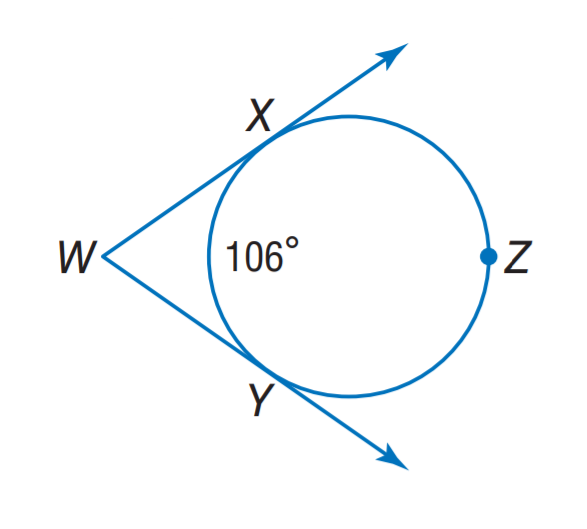Answer the mathemtical geometry problem and directly provide the correct option letter.
Question: Find m \angle W.
Choices: A: 74 B: 76 C: 104 D: 106 A 